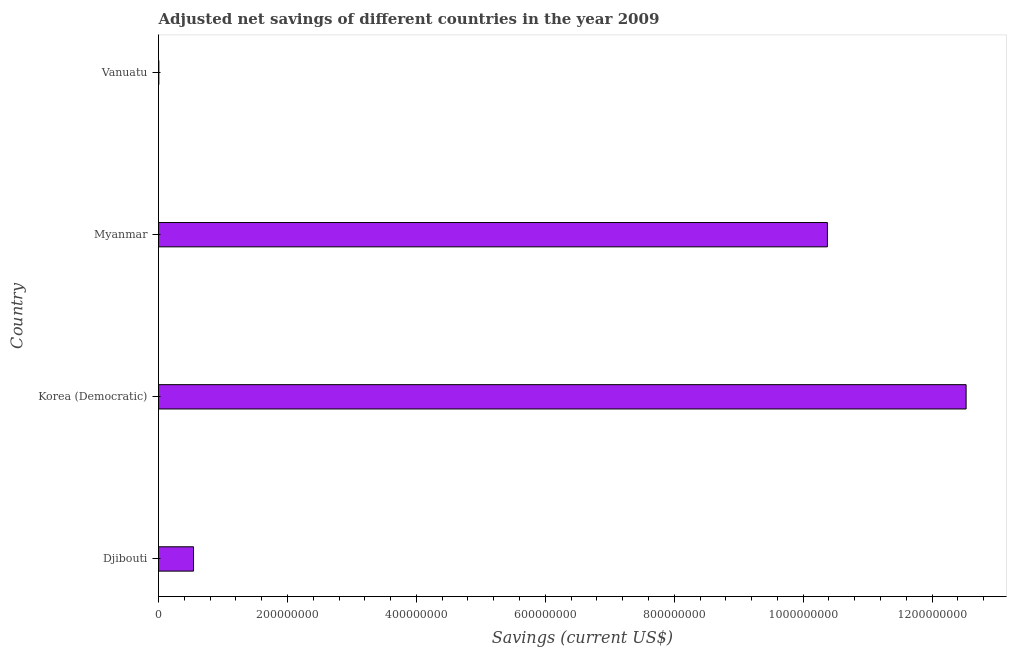Does the graph contain any zero values?
Offer a very short reply. No. Does the graph contain grids?
Your answer should be very brief. No. What is the title of the graph?
Your answer should be compact. Adjusted net savings of different countries in the year 2009. What is the label or title of the X-axis?
Provide a succinct answer. Savings (current US$). What is the adjusted net savings in Myanmar?
Keep it short and to the point. 1.04e+09. Across all countries, what is the maximum adjusted net savings?
Offer a terse response. 1.25e+09. Across all countries, what is the minimum adjusted net savings?
Give a very brief answer. 5.18e+05. In which country was the adjusted net savings maximum?
Keep it short and to the point. Korea (Democratic). In which country was the adjusted net savings minimum?
Offer a very short reply. Vanuatu. What is the sum of the adjusted net savings?
Give a very brief answer. 2.35e+09. What is the difference between the adjusted net savings in Djibouti and Vanuatu?
Offer a terse response. 5.38e+07. What is the average adjusted net savings per country?
Offer a very short reply. 5.86e+08. What is the median adjusted net savings?
Offer a very short reply. 5.46e+08. In how many countries, is the adjusted net savings greater than 920000000 US$?
Offer a very short reply. 2. What is the ratio of the adjusted net savings in Myanmar to that in Vanuatu?
Offer a terse response. 2002.34. Is the difference between the adjusted net savings in Myanmar and Vanuatu greater than the difference between any two countries?
Give a very brief answer. No. What is the difference between the highest and the second highest adjusted net savings?
Your response must be concise. 2.15e+08. What is the difference between the highest and the lowest adjusted net savings?
Provide a short and direct response. 1.25e+09. In how many countries, is the adjusted net savings greater than the average adjusted net savings taken over all countries?
Keep it short and to the point. 2. How many bars are there?
Provide a short and direct response. 4. What is the difference between two consecutive major ticks on the X-axis?
Keep it short and to the point. 2.00e+08. Are the values on the major ticks of X-axis written in scientific E-notation?
Offer a very short reply. No. What is the Savings (current US$) of Djibouti?
Give a very brief answer. 5.43e+07. What is the Savings (current US$) of Korea (Democratic)?
Offer a very short reply. 1.25e+09. What is the Savings (current US$) of Myanmar?
Your response must be concise. 1.04e+09. What is the Savings (current US$) in Vanuatu?
Make the answer very short. 5.18e+05. What is the difference between the Savings (current US$) in Djibouti and Korea (Democratic)?
Provide a succinct answer. -1.20e+09. What is the difference between the Savings (current US$) in Djibouti and Myanmar?
Your answer should be very brief. -9.83e+08. What is the difference between the Savings (current US$) in Djibouti and Vanuatu?
Provide a short and direct response. 5.38e+07. What is the difference between the Savings (current US$) in Korea (Democratic) and Myanmar?
Offer a terse response. 2.15e+08. What is the difference between the Savings (current US$) in Korea (Democratic) and Vanuatu?
Make the answer very short. 1.25e+09. What is the difference between the Savings (current US$) in Myanmar and Vanuatu?
Your answer should be compact. 1.04e+09. What is the ratio of the Savings (current US$) in Djibouti to that in Korea (Democratic)?
Offer a terse response. 0.04. What is the ratio of the Savings (current US$) in Djibouti to that in Myanmar?
Offer a very short reply. 0.05. What is the ratio of the Savings (current US$) in Djibouti to that in Vanuatu?
Give a very brief answer. 104.81. What is the ratio of the Savings (current US$) in Korea (Democratic) to that in Myanmar?
Offer a terse response. 1.21. What is the ratio of the Savings (current US$) in Korea (Democratic) to that in Vanuatu?
Your answer should be compact. 2417.55. What is the ratio of the Savings (current US$) in Myanmar to that in Vanuatu?
Offer a very short reply. 2002.34. 